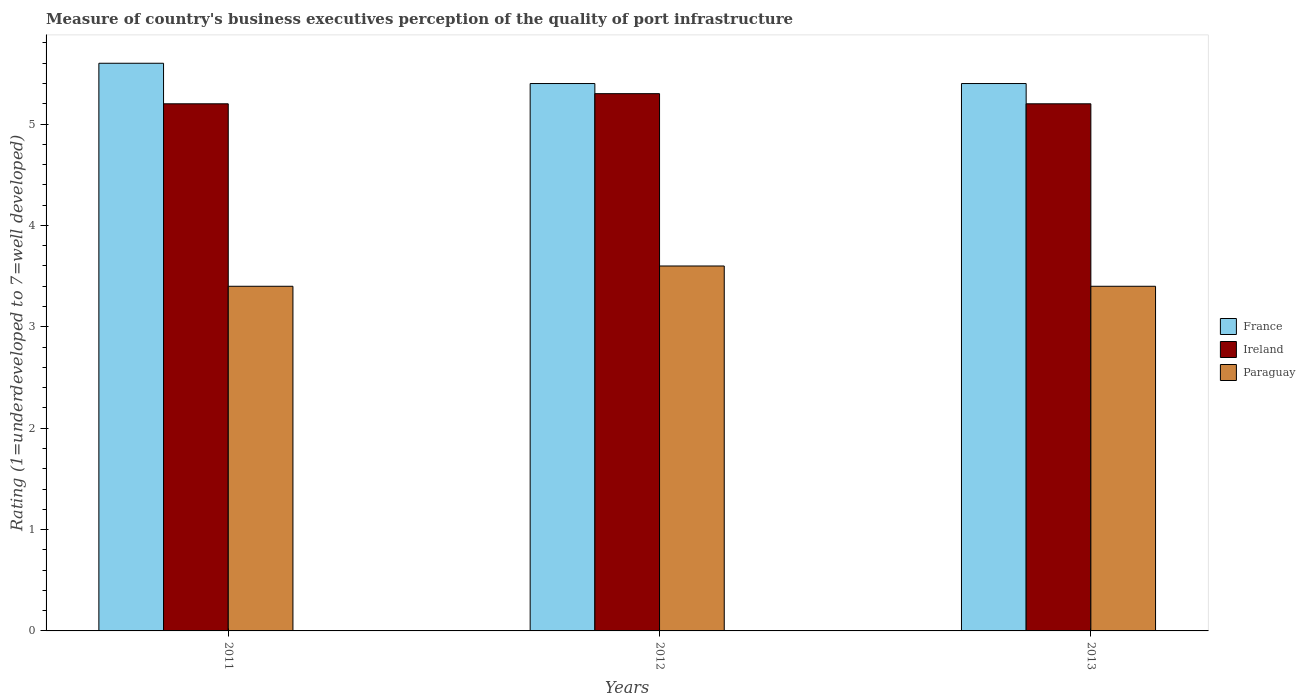Are the number of bars per tick equal to the number of legend labels?
Your answer should be compact. Yes. Are the number of bars on each tick of the X-axis equal?
Offer a very short reply. Yes. How many bars are there on the 3rd tick from the left?
Give a very brief answer. 3. What is the label of the 1st group of bars from the left?
Offer a very short reply. 2011. In how many cases, is the number of bars for a given year not equal to the number of legend labels?
Provide a succinct answer. 0. In which year was the ratings of the quality of port infrastructure in France minimum?
Your answer should be compact. 2012. What is the total ratings of the quality of port infrastructure in Ireland in the graph?
Give a very brief answer. 15.7. What is the difference between the ratings of the quality of port infrastructure in France in 2011 and the ratings of the quality of port infrastructure in Ireland in 2013?
Your response must be concise. 0.4. What is the average ratings of the quality of port infrastructure in Paraguay per year?
Your response must be concise. 3.47. In the year 2012, what is the difference between the ratings of the quality of port infrastructure in France and ratings of the quality of port infrastructure in Paraguay?
Offer a very short reply. 1.8. In how many years, is the ratings of the quality of port infrastructure in France greater than 4.6?
Keep it short and to the point. 3. What is the ratio of the ratings of the quality of port infrastructure in Paraguay in 2011 to that in 2013?
Offer a very short reply. 1. Is the difference between the ratings of the quality of port infrastructure in France in 2012 and 2013 greater than the difference between the ratings of the quality of port infrastructure in Paraguay in 2012 and 2013?
Keep it short and to the point. No. What is the difference between the highest and the second highest ratings of the quality of port infrastructure in Paraguay?
Your response must be concise. 0.2. What is the difference between the highest and the lowest ratings of the quality of port infrastructure in Paraguay?
Ensure brevity in your answer.  0.2. What does the 1st bar from the right in 2012 represents?
Keep it short and to the point. Paraguay. How many bars are there?
Your response must be concise. 9. Are the values on the major ticks of Y-axis written in scientific E-notation?
Give a very brief answer. No. Does the graph contain grids?
Your answer should be compact. No. How many legend labels are there?
Your answer should be compact. 3. What is the title of the graph?
Make the answer very short. Measure of country's business executives perception of the quality of port infrastructure. Does "Nepal" appear as one of the legend labels in the graph?
Make the answer very short. No. What is the label or title of the Y-axis?
Your answer should be very brief. Rating (1=underdeveloped to 7=well developed). What is the Rating (1=underdeveloped to 7=well developed) in Paraguay in 2011?
Make the answer very short. 3.4. What is the Rating (1=underdeveloped to 7=well developed) in Ireland in 2012?
Your response must be concise. 5.3. What is the Rating (1=underdeveloped to 7=well developed) of Paraguay in 2012?
Give a very brief answer. 3.6. Across all years, what is the maximum Rating (1=underdeveloped to 7=well developed) in France?
Ensure brevity in your answer.  5.6. Across all years, what is the maximum Rating (1=underdeveloped to 7=well developed) in Ireland?
Make the answer very short. 5.3. Across all years, what is the maximum Rating (1=underdeveloped to 7=well developed) in Paraguay?
Your response must be concise. 3.6. Across all years, what is the minimum Rating (1=underdeveloped to 7=well developed) in Ireland?
Provide a succinct answer. 5.2. What is the total Rating (1=underdeveloped to 7=well developed) of Ireland in the graph?
Offer a terse response. 15.7. What is the difference between the Rating (1=underdeveloped to 7=well developed) of France in 2011 and that in 2013?
Offer a terse response. 0.2. What is the difference between the Rating (1=underdeveloped to 7=well developed) of Ireland in 2011 and that in 2013?
Your answer should be very brief. 0. What is the difference between the Rating (1=underdeveloped to 7=well developed) of France in 2012 and that in 2013?
Provide a short and direct response. 0. What is the difference between the Rating (1=underdeveloped to 7=well developed) of Ireland in 2012 and that in 2013?
Keep it short and to the point. 0.1. What is the difference between the Rating (1=underdeveloped to 7=well developed) in Paraguay in 2012 and that in 2013?
Give a very brief answer. 0.2. What is the difference between the Rating (1=underdeveloped to 7=well developed) in France in 2011 and the Rating (1=underdeveloped to 7=well developed) in Paraguay in 2012?
Your response must be concise. 2. What is the difference between the Rating (1=underdeveloped to 7=well developed) of Ireland in 2011 and the Rating (1=underdeveloped to 7=well developed) of Paraguay in 2013?
Your answer should be compact. 1.8. What is the difference between the Rating (1=underdeveloped to 7=well developed) in France in 2012 and the Rating (1=underdeveloped to 7=well developed) in Ireland in 2013?
Offer a very short reply. 0.2. What is the average Rating (1=underdeveloped to 7=well developed) in France per year?
Provide a short and direct response. 5.47. What is the average Rating (1=underdeveloped to 7=well developed) in Ireland per year?
Keep it short and to the point. 5.23. What is the average Rating (1=underdeveloped to 7=well developed) in Paraguay per year?
Offer a terse response. 3.47. In the year 2011, what is the difference between the Rating (1=underdeveloped to 7=well developed) of France and Rating (1=underdeveloped to 7=well developed) of Ireland?
Your response must be concise. 0.4. In the year 2011, what is the difference between the Rating (1=underdeveloped to 7=well developed) in France and Rating (1=underdeveloped to 7=well developed) in Paraguay?
Your response must be concise. 2.2. In the year 2012, what is the difference between the Rating (1=underdeveloped to 7=well developed) in France and Rating (1=underdeveloped to 7=well developed) in Paraguay?
Ensure brevity in your answer.  1.8. In the year 2012, what is the difference between the Rating (1=underdeveloped to 7=well developed) of Ireland and Rating (1=underdeveloped to 7=well developed) of Paraguay?
Your response must be concise. 1.7. What is the ratio of the Rating (1=underdeveloped to 7=well developed) of France in 2011 to that in 2012?
Provide a short and direct response. 1.04. What is the ratio of the Rating (1=underdeveloped to 7=well developed) of Ireland in 2011 to that in 2012?
Make the answer very short. 0.98. What is the ratio of the Rating (1=underdeveloped to 7=well developed) in Ireland in 2011 to that in 2013?
Keep it short and to the point. 1. What is the ratio of the Rating (1=underdeveloped to 7=well developed) in Ireland in 2012 to that in 2013?
Provide a succinct answer. 1.02. What is the ratio of the Rating (1=underdeveloped to 7=well developed) of Paraguay in 2012 to that in 2013?
Offer a very short reply. 1.06. What is the difference between the highest and the second highest Rating (1=underdeveloped to 7=well developed) of Ireland?
Offer a very short reply. 0.1. What is the difference between the highest and the lowest Rating (1=underdeveloped to 7=well developed) of Ireland?
Your response must be concise. 0.1. What is the difference between the highest and the lowest Rating (1=underdeveloped to 7=well developed) in Paraguay?
Provide a short and direct response. 0.2. 